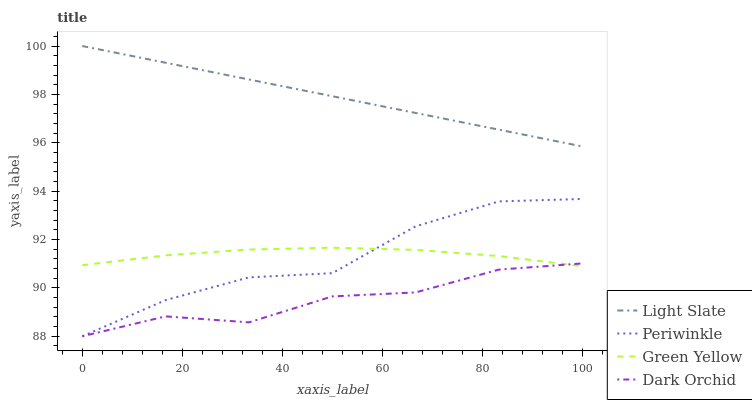Does Dark Orchid have the minimum area under the curve?
Answer yes or no. Yes. Does Light Slate have the maximum area under the curve?
Answer yes or no. Yes. Does Green Yellow have the minimum area under the curve?
Answer yes or no. No. Does Green Yellow have the maximum area under the curve?
Answer yes or no. No. Is Light Slate the smoothest?
Answer yes or no. Yes. Is Periwinkle the roughest?
Answer yes or no. Yes. Is Green Yellow the smoothest?
Answer yes or no. No. Is Green Yellow the roughest?
Answer yes or no. No. Does Periwinkle have the lowest value?
Answer yes or no. Yes. Does Green Yellow have the lowest value?
Answer yes or no. No. Does Light Slate have the highest value?
Answer yes or no. Yes. Does Green Yellow have the highest value?
Answer yes or no. No. Is Periwinkle less than Light Slate?
Answer yes or no. Yes. Is Light Slate greater than Dark Orchid?
Answer yes or no. Yes. Does Dark Orchid intersect Periwinkle?
Answer yes or no. Yes. Is Dark Orchid less than Periwinkle?
Answer yes or no. No. Is Dark Orchid greater than Periwinkle?
Answer yes or no. No. Does Periwinkle intersect Light Slate?
Answer yes or no. No. 